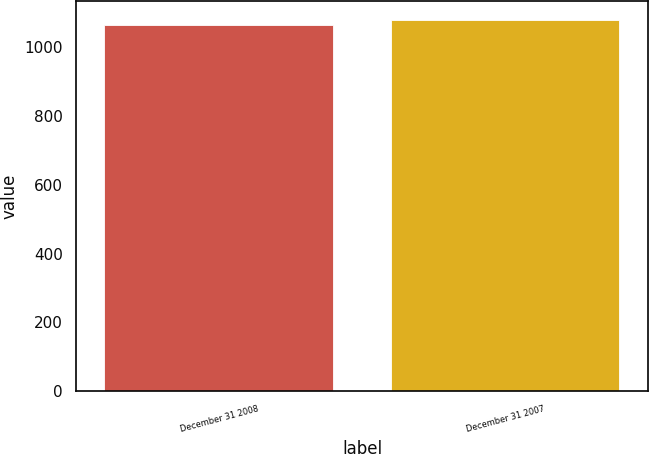Convert chart. <chart><loc_0><loc_0><loc_500><loc_500><bar_chart><fcel>December 31 2008<fcel>December 31 2007<nl><fcel>1064<fcel>1079<nl></chart> 